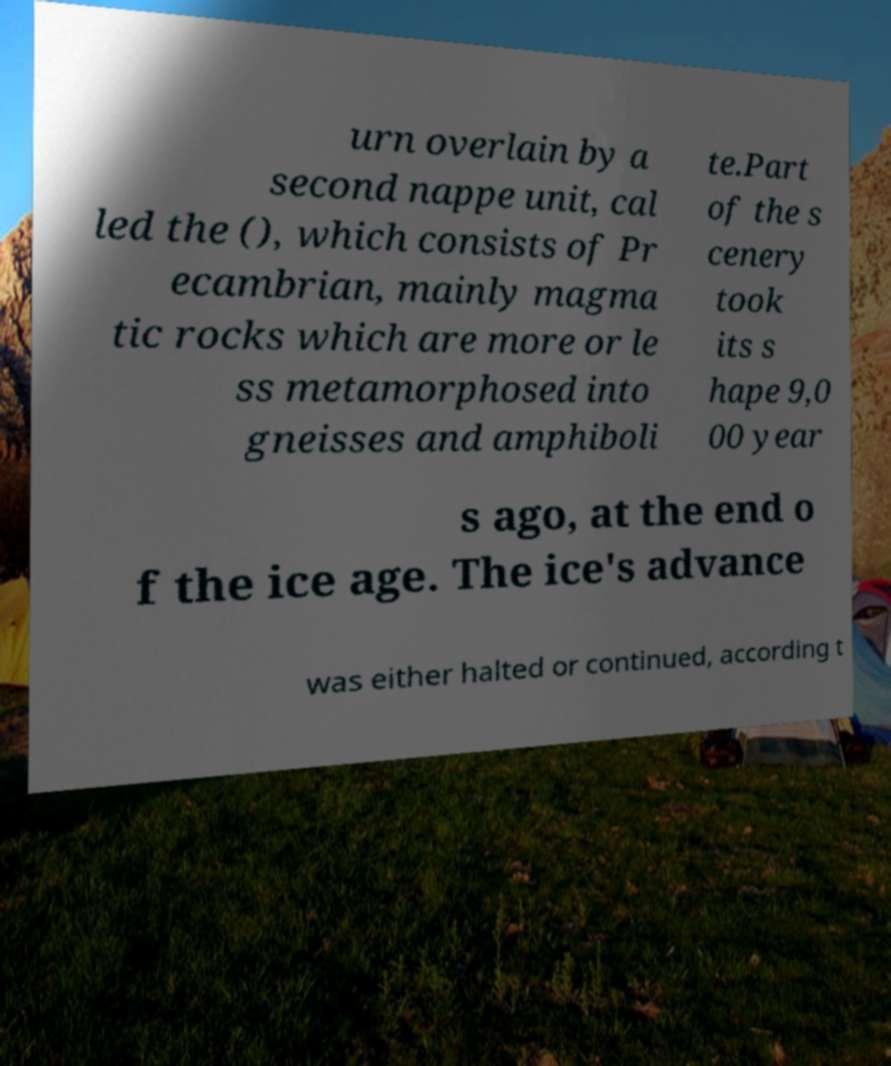I need the written content from this picture converted into text. Can you do that? urn overlain by a second nappe unit, cal led the (), which consists of Pr ecambrian, mainly magma tic rocks which are more or le ss metamorphosed into gneisses and amphiboli te.Part of the s cenery took its s hape 9,0 00 year s ago, at the end o f the ice age. The ice's advance was either halted or continued, according t 